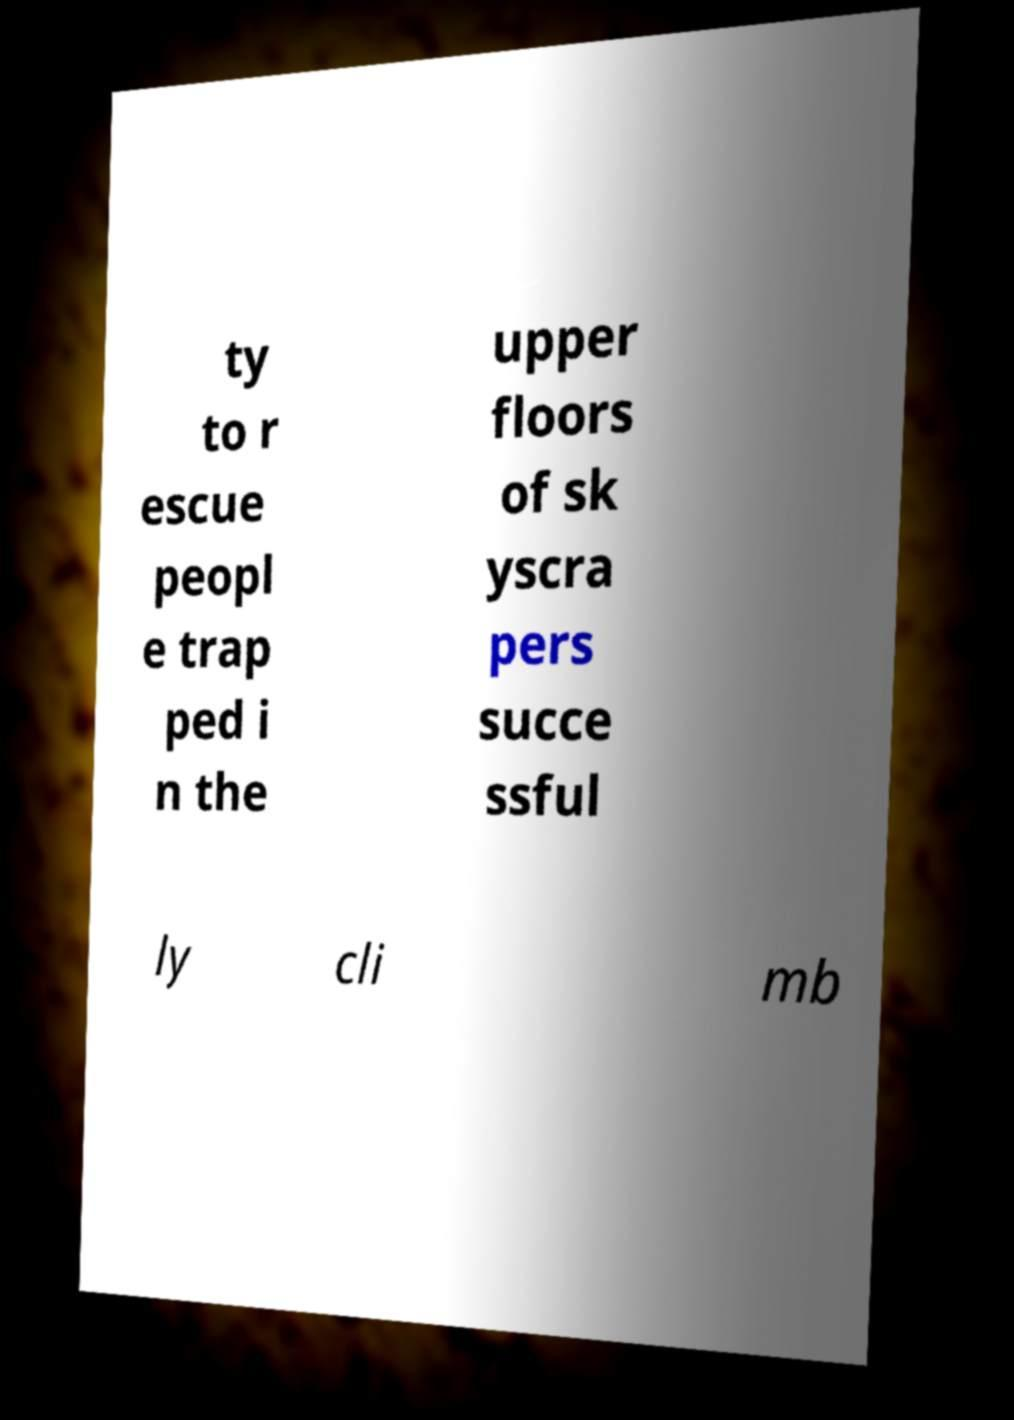Could you extract and type out the text from this image? ty to r escue peopl e trap ped i n the upper floors of sk yscra pers succe ssful ly cli mb 